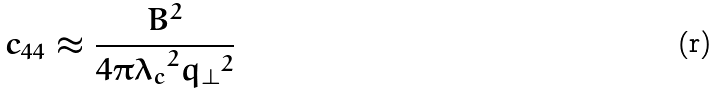<formula> <loc_0><loc_0><loc_500><loc_500>c _ { 4 4 } \approx \frac { B ^ { 2 } } { 4 \pi { \lambda _ { c } } ^ { 2 } { q _ { \perp } } ^ { 2 } }</formula> 